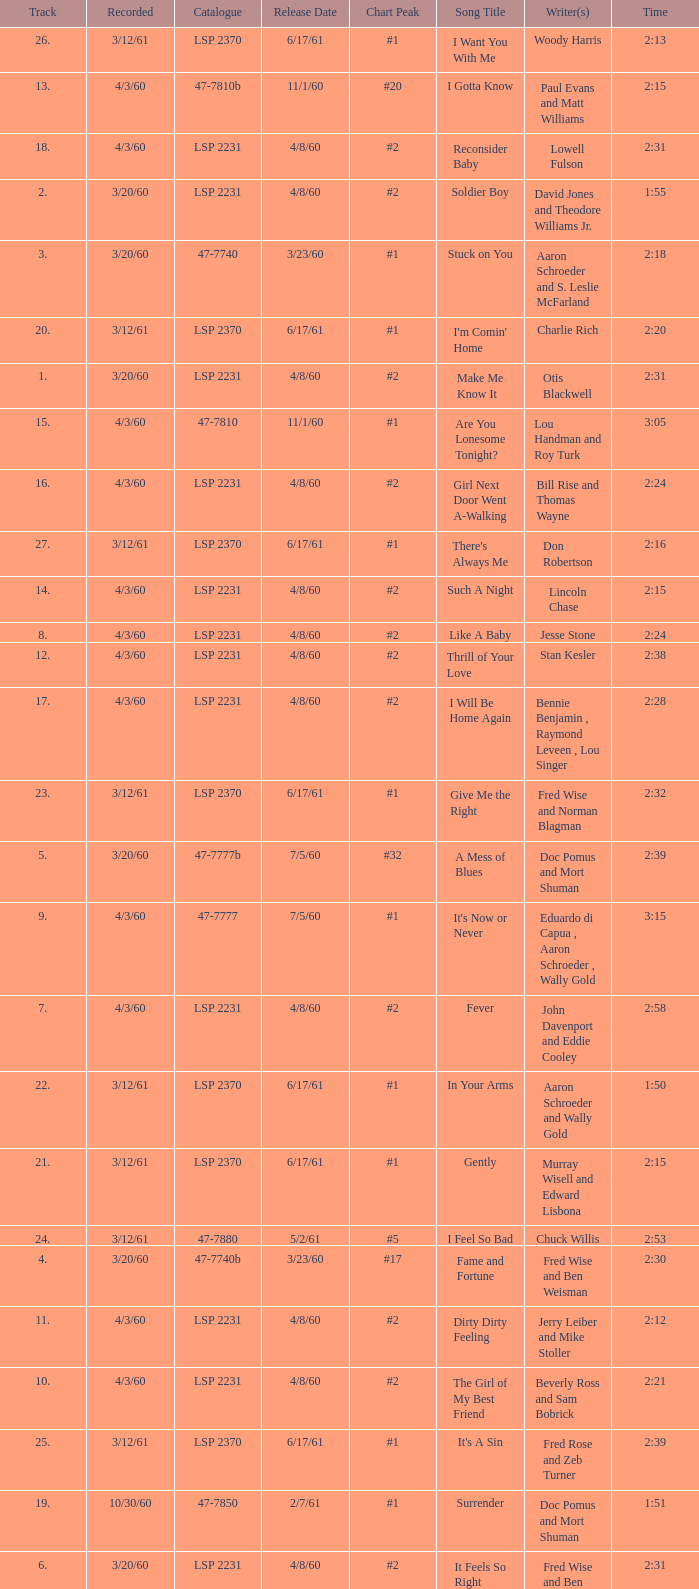What is the time of songs that have the writer Aaron Schroeder and Wally Gold? 1:50. 